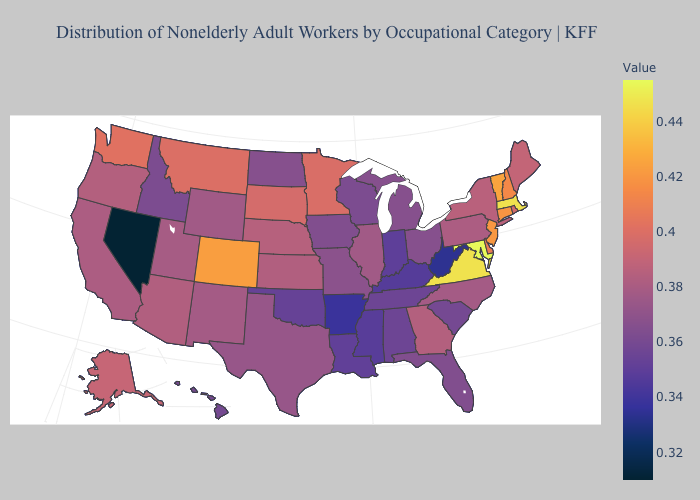Which states have the lowest value in the USA?
Answer briefly. Nevada. Does the map have missing data?
Be succinct. No. Which states have the lowest value in the USA?
Short answer required. Nevada. Which states have the lowest value in the MidWest?
Answer briefly. Indiana. Which states have the lowest value in the USA?
Concise answer only. Nevada. Among the states that border Michigan , does Wisconsin have the highest value?
Concise answer only. No. 